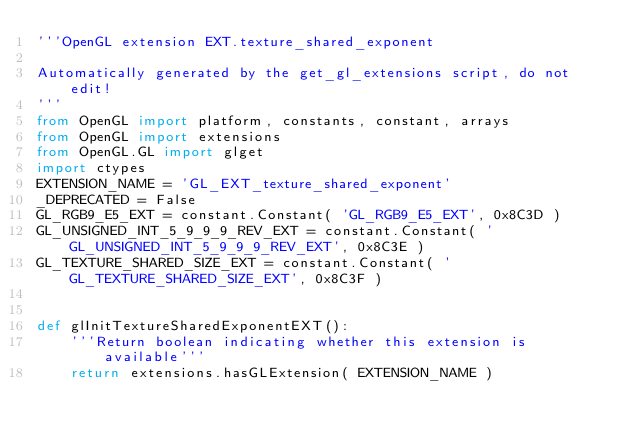<code> <loc_0><loc_0><loc_500><loc_500><_Python_>'''OpenGL extension EXT.texture_shared_exponent

Automatically generated by the get_gl_extensions script, do not edit!
'''
from OpenGL import platform, constants, constant, arrays
from OpenGL import extensions
from OpenGL.GL import glget
import ctypes
EXTENSION_NAME = 'GL_EXT_texture_shared_exponent'
_DEPRECATED = False
GL_RGB9_E5_EXT = constant.Constant( 'GL_RGB9_E5_EXT', 0x8C3D )
GL_UNSIGNED_INT_5_9_9_9_REV_EXT = constant.Constant( 'GL_UNSIGNED_INT_5_9_9_9_REV_EXT', 0x8C3E )
GL_TEXTURE_SHARED_SIZE_EXT = constant.Constant( 'GL_TEXTURE_SHARED_SIZE_EXT', 0x8C3F )


def glInitTextureSharedExponentEXT():
    '''Return boolean indicating whether this extension is available'''
    return extensions.hasGLExtension( EXTENSION_NAME )
</code> 